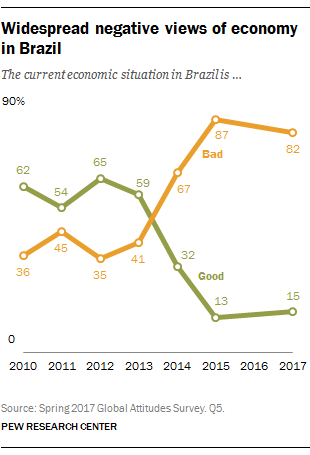Draw attention to some important aspects in this diagram. In 2013, the orange line crossed over the green line. This text asks how many years of data are compared in the chart. 